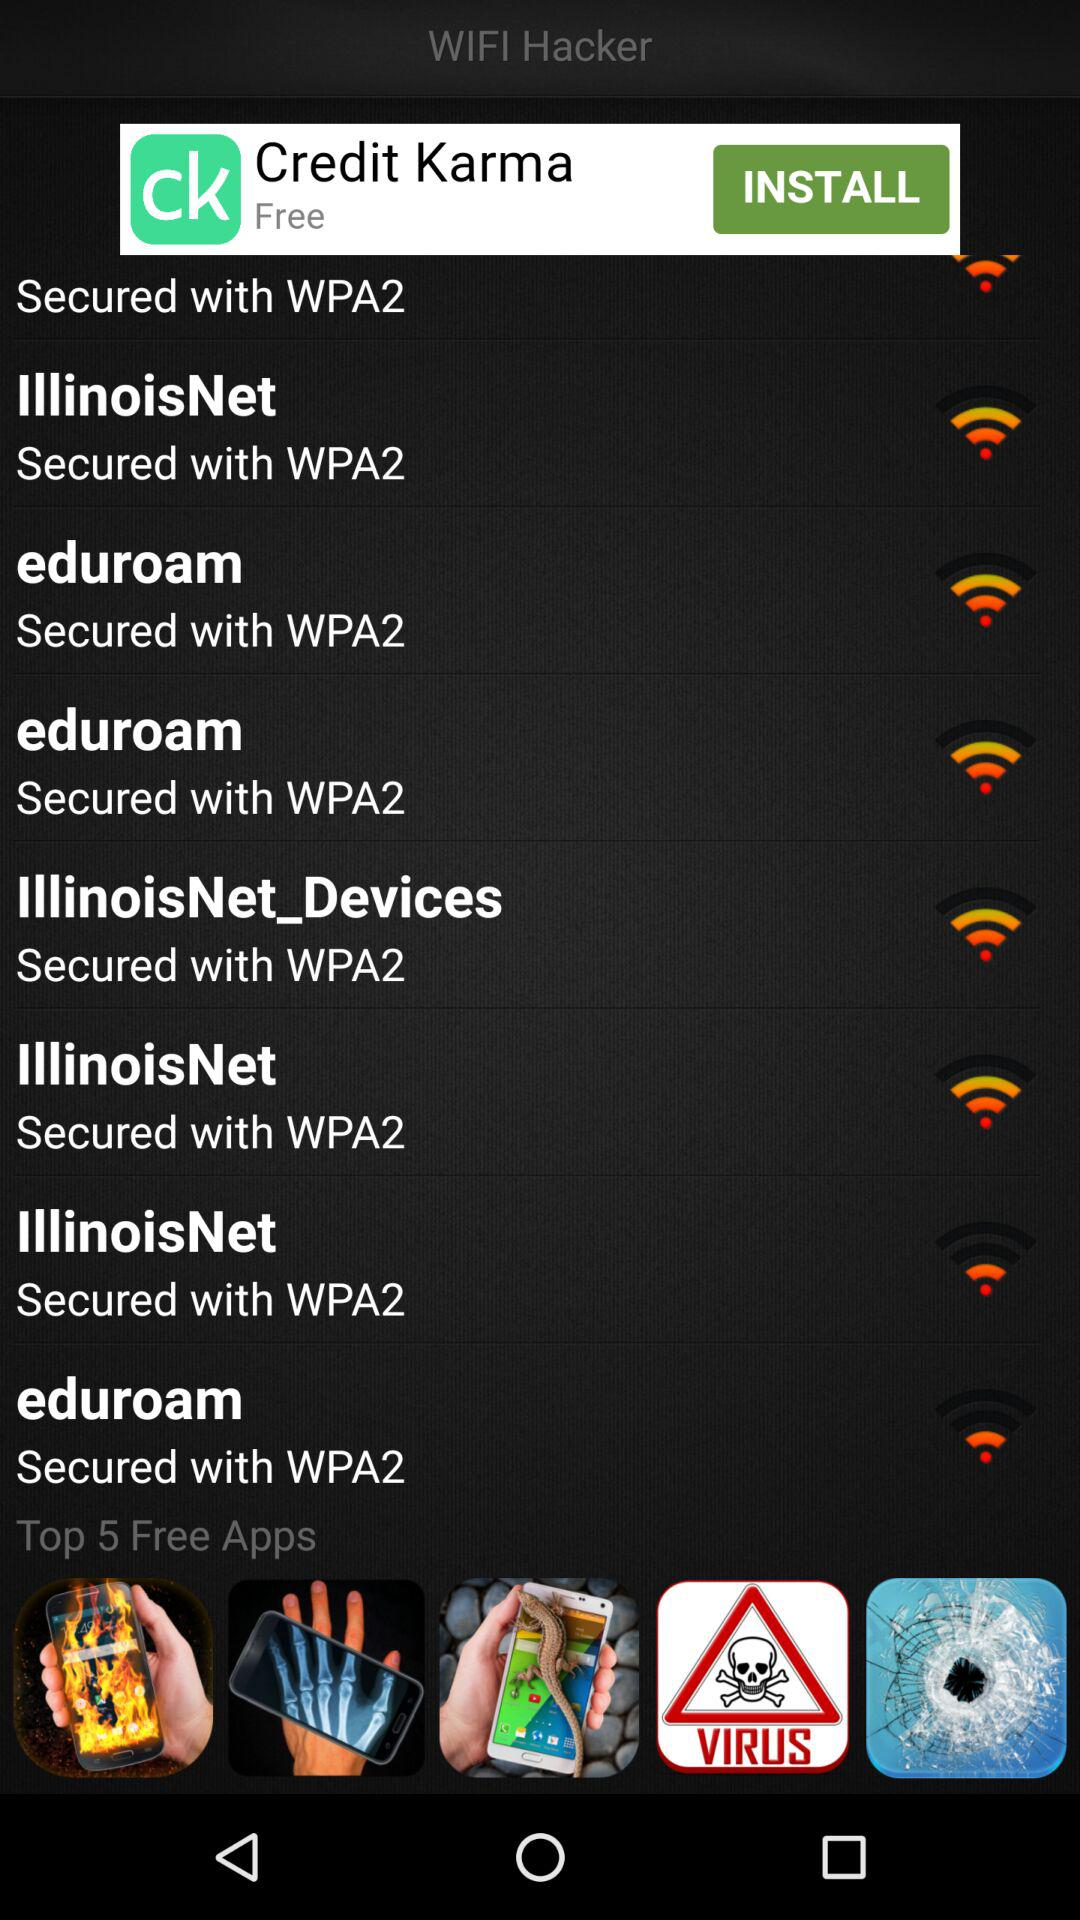What is the name of the application? The name of the application is "WIFI Hacker". 